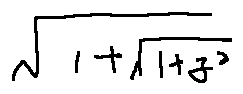Convert formula to latex. <formula><loc_0><loc_0><loc_500><loc_500>\sqrt { 1 + \sqrt { 1 + z ^ { 2 } } }</formula> 